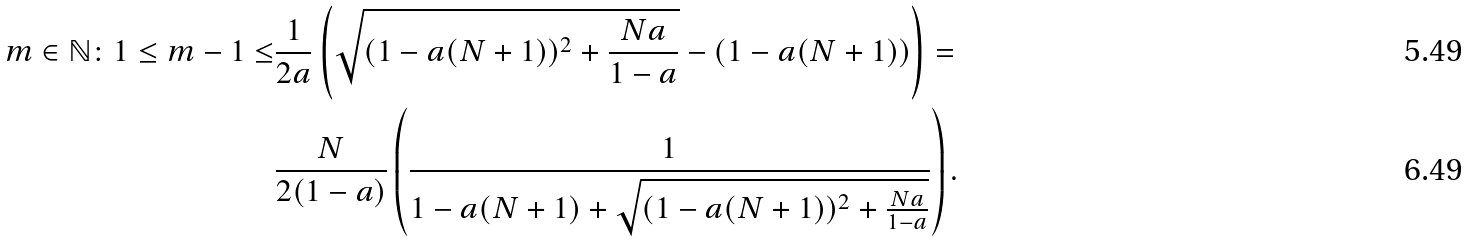Convert formula to latex. <formula><loc_0><loc_0><loc_500><loc_500>m \in \mathbb { N } \colon 1 \leq m - 1 \leq & \frac { 1 } { 2 a } \left ( \sqrt { ( 1 - a ( N + 1 ) ) ^ { 2 } + \frac { N a } { 1 - a } } - ( 1 - a ( N + 1 ) ) \right ) = \\ & \frac { N } { 2 ( 1 - a ) } \left ( \frac { 1 } { 1 - a ( N + 1 ) + \sqrt { ( 1 - a ( N + 1 ) ) ^ { 2 } + \frac { N a } { 1 - a } } } \right ) .</formula> 